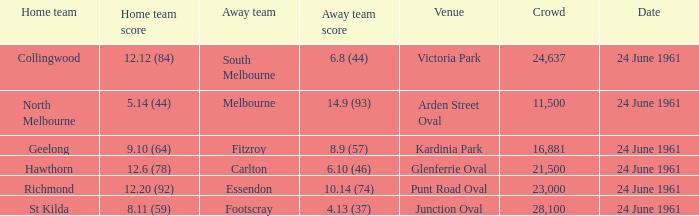What was the average crowd size of games held at Glenferrie Oval? 21500.0. 